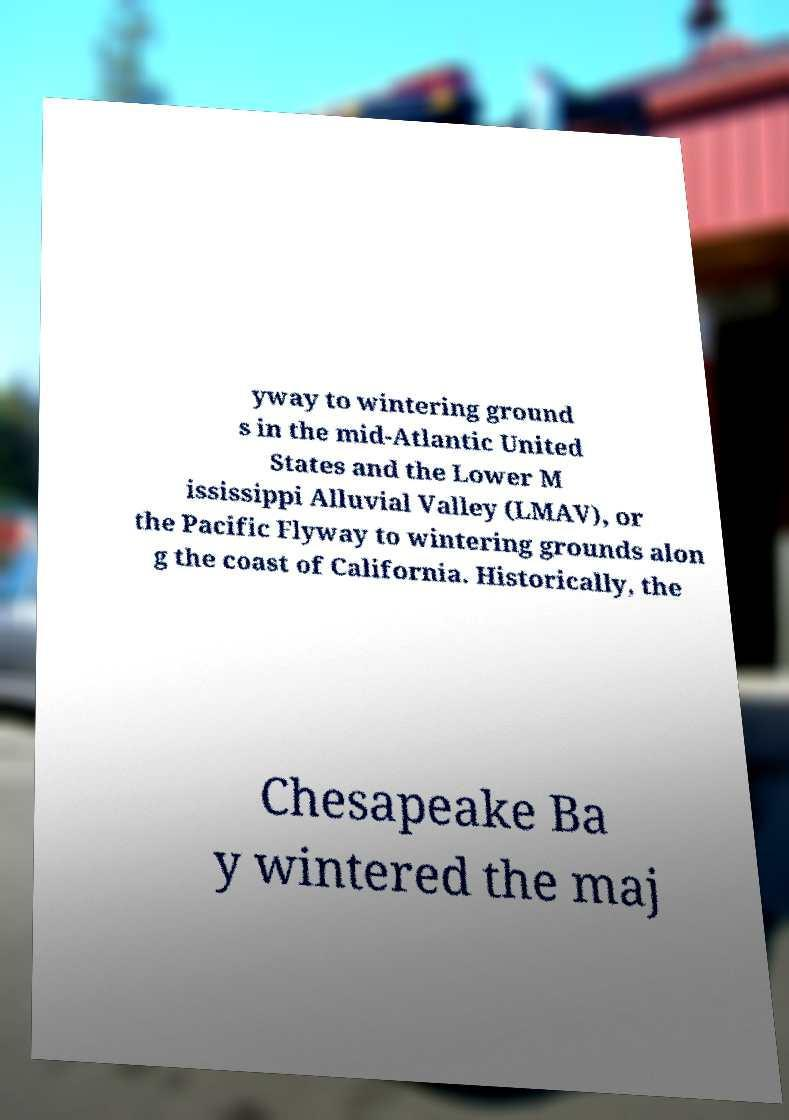For documentation purposes, I need the text within this image transcribed. Could you provide that? yway to wintering ground s in the mid-Atlantic United States and the Lower M ississippi Alluvial Valley (LMAV), or the Pacific Flyway to wintering grounds alon g the coast of California. Historically, the Chesapeake Ba y wintered the maj 